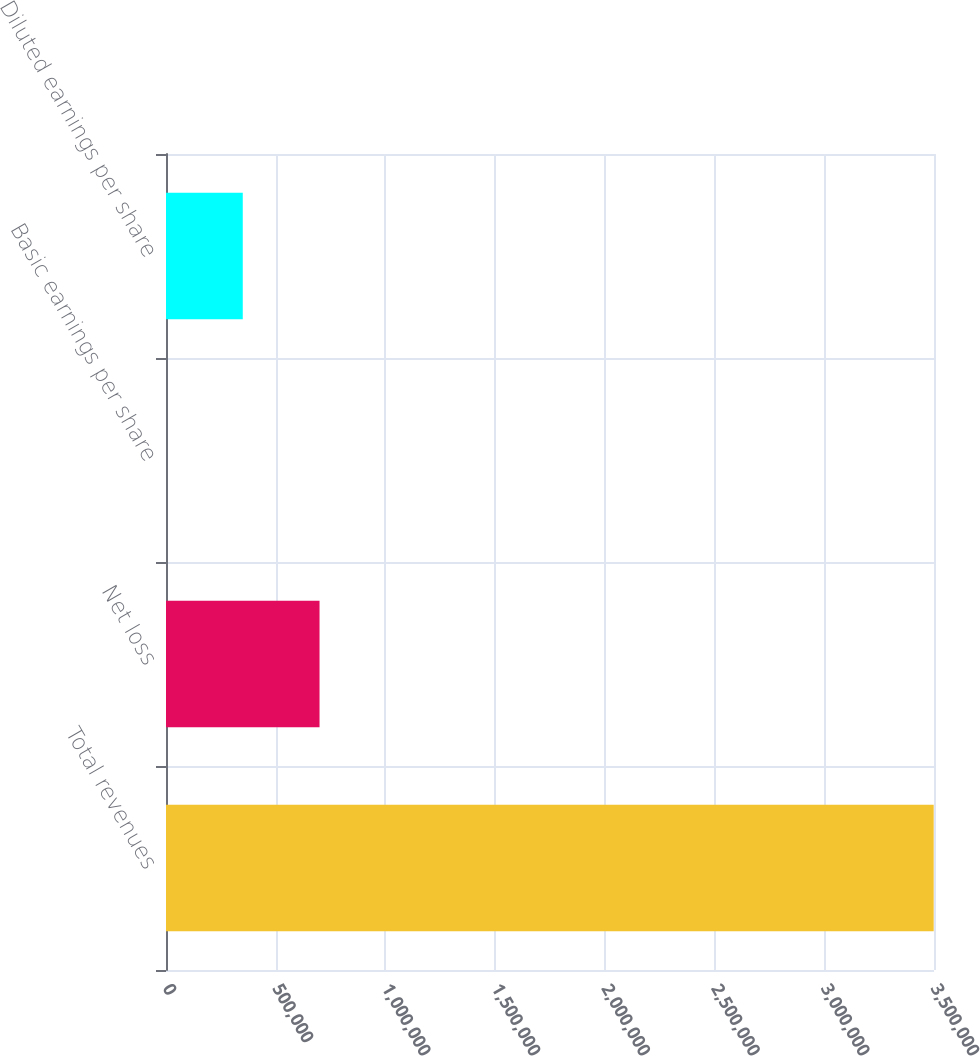Convert chart to OTSL. <chart><loc_0><loc_0><loc_500><loc_500><bar_chart><fcel>Total revenues<fcel>Net loss<fcel>Basic earnings per share<fcel>Diluted earnings per share<nl><fcel>3.49857e+06<fcel>699715<fcel>1.52<fcel>349858<nl></chart> 